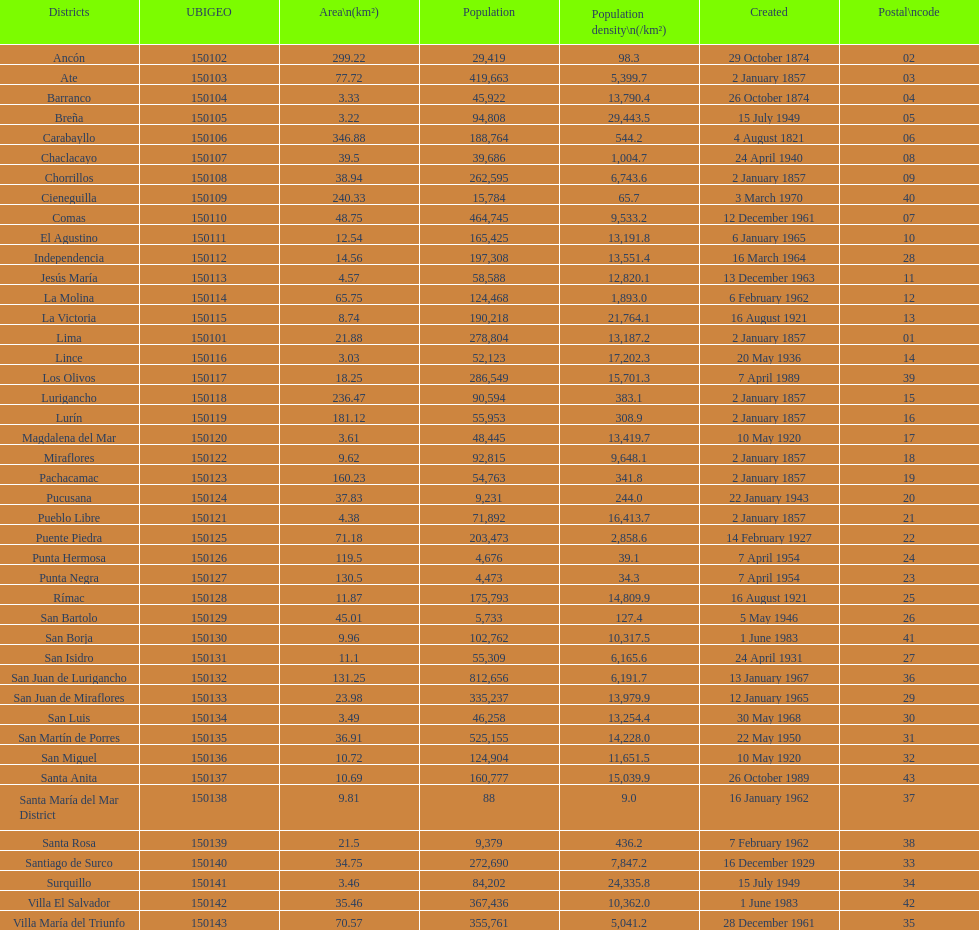What district has the least amount of population? Santa María del Mar District. Help me parse the entirety of this table. {'header': ['Districts', 'UBIGEO', 'Area\\n(km²)', 'Population', 'Population density\\n(/km²)', 'Created', 'Postal\\ncode'], 'rows': [['Ancón', '150102', '299.22', '29,419', '98.3', '29 October 1874', '02'], ['Ate', '150103', '77.72', '419,663', '5,399.7', '2 January 1857', '03'], ['Barranco', '150104', '3.33', '45,922', '13,790.4', '26 October 1874', '04'], ['Breña', '150105', '3.22', '94,808', '29,443.5', '15 July 1949', '05'], ['Carabayllo', '150106', '346.88', '188,764', '544.2', '4 August 1821', '06'], ['Chaclacayo', '150107', '39.5', '39,686', '1,004.7', '24 April 1940', '08'], ['Chorrillos', '150108', '38.94', '262,595', '6,743.6', '2 January 1857', '09'], ['Cieneguilla', '150109', '240.33', '15,784', '65.7', '3 March 1970', '40'], ['Comas', '150110', '48.75', '464,745', '9,533.2', '12 December 1961', '07'], ['El Agustino', '150111', '12.54', '165,425', '13,191.8', '6 January 1965', '10'], ['Independencia', '150112', '14.56', '197,308', '13,551.4', '16 March 1964', '28'], ['Jesús María', '150113', '4.57', '58,588', '12,820.1', '13 December 1963', '11'], ['La Molina', '150114', '65.75', '124,468', '1,893.0', '6 February 1962', '12'], ['La Victoria', '150115', '8.74', '190,218', '21,764.1', '16 August 1921', '13'], ['Lima', '150101', '21.88', '278,804', '13,187.2', '2 January 1857', '01'], ['Lince', '150116', '3.03', '52,123', '17,202.3', '20 May 1936', '14'], ['Los Olivos', '150117', '18.25', '286,549', '15,701.3', '7 April 1989', '39'], ['Lurigancho', '150118', '236.47', '90,594', '383.1', '2 January 1857', '15'], ['Lurín', '150119', '181.12', '55,953', '308.9', '2 January 1857', '16'], ['Magdalena del Mar', '150120', '3.61', '48,445', '13,419.7', '10 May 1920', '17'], ['Miraflores', '150122', '9.62', '92,815', '9,648.1', '2 January 1857', '18'], ['Pachacamac', '150123', '160.23', '54,763', '341.8', '2 January 1857', '19'], ['Pucusana', '150124', '37.83', '9,231', '244.0', '22 January 1943', '20'], ['Pueblo Libre', '150121', '4.38', '71,892', '16,413.7', '2 January 1857', '21'], ['Puente Piedra', '150125', '71.18', '203,473', '2,858.6', '14 February 1927', '22'], ['Punta Hermosa', '150126', '119.5', '4,676', '39.1', '7 April 1954', '24'], ['Punta Negra', '150127', '130.5', '4,473', '34.3', '7 April 1954', '23'], ['Rímac', '150128', '11.87', '175,793', '14,809.9', '16 August 1921', '25'], ['San Bartolo', '150129', '45.01', '5,733', '127.4', '5 May 1946', '26'], ['San Borja', '150130', '9.96', '102,762', '10,317.5', '1 June 1983', '41'], ['San Isidro', '150131', '11.1', '55,309', '6,165.6', '24 April 1931', '27'], ['San Juan de Lurigancho', '150132', '131.25', '812,656', '6,191.7', '13 January 1967', '36'], ['San Juan de Miraflores', '150133', '23.98', '335,237', '13,979.9', '12 January 1965', '29'], ['San Luis', '150134', '3.49', '46,258', '13,254.4', '30 May 1968', '30'], ['San Martín de Porres', '150135', '36.91', '525,155', '14,228.0', '22 May 1950', '31'], ['San Miguel', '150136', '10.72', '124,904', '11,651.5', '10 May 1920', '32'], ['Santa Anita', '150137', '10.69', '160,777', '15,039.9', '26 October 1989', '43'], ['Santa María del Mar District', '150138', '9.81', '88', '9.0', '16 January 1962', '37'], ['Santa Rosa', '150139', '21.5', '9,379', '436.2', '7 February 1962', '38'], ['Santiago de Surco', '150140', '34.75', '272,690', '7,847.2', '16 December 1929', '33'], ['Surquillo', '150141', '3.46', '84,202', '24,335.8', '15 July 1949', '34'], ['Villa El Salvador', '150142', '35.46', '367,436', '10,362.0', '1 June 1983', '42'], ['Villa María del Triunfo', '150143', '70.57', '355,761', '5,041.2', '28 December 1961', '35']]} 